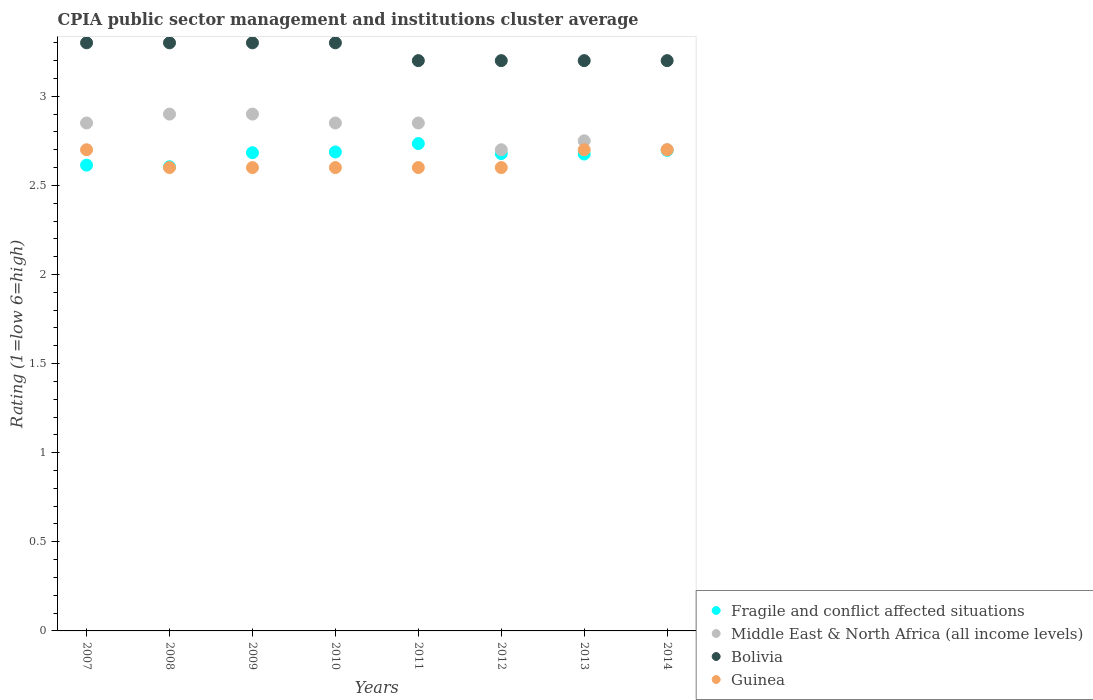Is the number of dotlines equal to the number of legend labels?
Make the answer very short. Yes. What is the CPIA rating in Fragile and conflict affected situations in 2008?
Ensure brevity in your answer.  2.6. Across all years, what is the maximum CPIA rating in Guinea?
Offer a terse response. 2.7. Across all years, what is the minimum CPIA rating in Fragile and conflict affected situations?
Offer a very short reply. 2.6. In which year was the CPIA rating in Middle East & North Africa (all income levels) maximum?
Make the answer very short. 2008. What is the total CPIA rating in Bolivia in the graph?
Make the answer very short. 26. What is the difference between the CPIA rating in Fragile and conflict affected situations in 2008 and that in 2013?
Keep it short and to the point. -0.07. What is the difference between the CPIA rating in Fragile and conflict affected situations in 2013 and the CPIA rating in Guinea in 2007?
Provide a short and direct response. -0.02. What is the average CPIA rating in Fragile and conflict affected situations per year?
Keep it short and to the point. 2.67. In the year 2007, what is the difference between the CPIA rating in Fragile and conflict affected situations and CPIA rating in Guinea?
Keep it short and to the point. -0.09. In how many years, is the CPIA rating in Middle East & North Africa (all income levels) greater than 0.8?
Your answer should be very brief. 8. Is the CPIA rating in Fragile and conflict affected situations in 2007 less than that in 2008?
Make the answer very short. No. Is the difference between the CPIA rating in Fragile and conflict affected situations in 2010 and 2013 greater than the difference between the CPIA rating in Guinea in 2010 and 2013?
Offer a terse response. Yes. What is the difference between the highest and the lowest CPIA rating in Bolivia?
Ensure brevity in your answer.  0.1. In how many years, is the CPIA rating in Middle East & North Africa (all income levels) greater than the average CPIA rating in Middle East & North Africa (all income levels) taken over all years?
Keep it short and to the point. 5. Is it the case that in every year, the sum of the CPIA rating in Bolivia and CPIA rating in Fragile and conflict affected situations  is greater than the sum of CPIA rating in Guinea and CPIA rating in Middle East & North Africa (all income levels)?
Provide a short and direct response. Yes. Does the CPIA rating in Middle East & North Africa (all income levels) monotonically increase over the years?
Your answer should be compact. No. Is the CPIA rating in Middle East & North Africa (all income levels) strictly less than the CPIA rating in Bolivia over the years?
Your answer should be very brief. Yes. How many dotlines are there?
Your answer should be very brief. 4. What is the difference between two consecutive major ticks on the Y-axis?
Keep it short and to the point. 0.5. Does the graph contain any zero values?
Provide a short and direct response. No. Does the graph contain grids?
Offer a very short reply. No. Where does the legend appear in the graph?
Provide a succinct answer. Bottom right. What is the title of the graph?
Keep it short and to the point. CPIA public sector management and institutions cluster average. What is the label or title of the Y-axis?
Give a very brief answer. Rating (1=low 6=high). What is the Rating (1=low 6=high) in Fragile and conflict affected situations in 2007?
Your answer should be compact. 2.61. What is the Rating (1=low 6=high) of Middle East & North Africa (all income levels) in 2007?
Your response must be concise. 2.85. What is the Rating (1=low 6=high) in Bolivia in 2007?
Provide a succinct answer. 3.3. What is the Rating (1=low 6=high) in Guinea in 2007?
Provide a succinct answer. 2.7. What is the Rating (1=low 6=high) in Fragile and conflict affected situations in 2008?
Keep it short and to the point. 2.6. What is the Rating (1=low 6=high) in Bolivia in 2008?
Provide a short and direct response. 3.3. What is the Rating (1=low 6=high) in Guinea in 2008?
Provide a succinct answer. 2.6. What is the Rating (1=low 6=high) of Fragile and conflict affected situations in 2009?
Offer a terse response. 2.68. What is the Rating (1=low 6=high) in Bolivia in 2009?
Give a very brief answer. 3.3. What is the Rating (1=low 6=high) of Fragile and conflict affected situations in 2010?
Keep it short and to the point. 2.69. What is the Rating (1=low 6=high) of Middle East & North Africa (all income levels) in 2010?
Ensure brevity in your answer.  2.85. What is the Rating (1=low 6=high) in Bolivia in 2010?
Ensure brevity in your answer.  3.3. What is the Rating (1=low 6=high) in Guinea in 2010?
Provide a succinct answer. 2.6. What is the Rating (1=low 6=high) of Fragile and conflict affected situations in 2011?
Ensure brevity in your answer.  2.73. What is the Rating (1=low 6=high) of Middle East & North Africa (all income levels) in 2011?
Offer a very short reply. 2.85. What is the Rating (1=low 6=high) of Bolivia in 2011?
Make the answer very short. 3.2. What is the Rating (1=low 6=high) in Fragile and conflict affected situations in 2012?
Provide a short and direct response. 2.68. What is the Rating (1=low 6=high) in Guinea in 2012?
Your answer should be very brief. 2.6. What is the Rating (1=low 6=high) of Fragile and conflict affected situations in 2013?
Provide a succinct answer. 2.68. What is the Rating (1=low 6=high) in Middle East & North Africa (all income levels) in 2013?
Your answer should be very brief. 2.75. What is the Rating (1=low 6=high) in Bolivia in 2013?
Your answer should be compact. 3.2. What is the Rating (1=low 6=high) of Guinea in 2013?
Give a very brief answer. 2.7. What is the Rating (1=low 6=high) of Fragile and conflict affected situations in 2014?
Your answer should be very brief. 2.7. What is the Rating (1=low 6=high) of Bolivia in 2014?
Give a very brief answer. 3.2. Across all years, what is the maximum Rating (1=low 6=high) of Fragile and conflict affected situations?
Your answer should be very brief. 2.73. Across all years, what is the maximum Rating (1=low 6=high) in Middle East & North Africa (all income levels)?
Give a very brief answer. 2.9. Across all years, what is the minimum Rating (1=low 6=high) in Fragile and conflict affected situations?
Ensure brevity in your answer.  2.6. Across all years, what is the minimum Rating (1=low 6=high) in Middle East & North Africa (all income levels)?
Your response must be concise. 2.7. Across all years, what is the minimum Rating (1=low 6=high) in Bolivia?
Ensure brevity in your answer.  3.2. What is the total Rating (1=low 6=high) of Fragile and conflict affected situations in the graph?
Provide a short and direct response. 21.37. What is the total Rating (1=low 6=high) of Middle East & North Africa (all income levels) in the graph?
Your answer should be very brief. 22.5. What is the total Rating (1=low 6=high) in Bolivia in the graph?
Provide a short and direct response. 26. What is the total Rating (1=low 6=high) of Guinea in the graph?
Provide a succinct answer. 21.1. What is the difference between the Rating (1=low 6=high) of Fragile and conflict affected situations in 2007 and that in 2008?
Provide a succinct answer. 0.01. What is the difference between the Rating (1=low 6=high) of Middle East & North Africa (all income levels) in 2007 and that in 2008?
Provide a succinct answer. -0.05. What is the difference between the Rating (1=low 6=high) of Bolivia in 2007 and that in 2008?
Your response must be concise. 0. What is the difference between the Rating (1=low 6=high) in Fragile and conflict affected situations in 2007 and that in 2009?
Offer a very short reply. -0.07. What is the difference between the Rating (1=low 6=high) in Fragile and conflict affected situations in 2007 and that in 2010?
Your answer should be compact. -0.07. What is the difference between the Rating (1=low 6=high) in Middle East & North Africa (all income levels) in 2007 and that in 2010?
Your answer should be compact. 0. What is the difference between the Rating (1=low 6=high) of Fragile and conflict affected situations in 2007 and that in 2011?
Ensure brevity in your answer.  -0.12. What is the difference between the Rating (1=low 6=high) of Middle East & North Africa (all income levels) in 2007 and that in 2011?
Keep it short and to the point. 0. What is the difference between the Rating (1=low 6=high) of Bolivia in 2007 and that in 2011?
Your answer should be compact. 0.1. What is the difference between the Rating (1=low 6=high) of Guinea in 2007 and that in 2011?
Ensure brevity in your answer.  0.1. What is the difference between the Rating (1=low 6=high) in Fragile and conflict affected situations in 2007 and that in 2012?
Ensure brevity in your answer.  -0.06. What is the difference between the Rating (1=low 6=high) in Middle East & North Africa (all income levels) in 2007 and that in 2012?
Provide a short and direct response. 0.15. What is the difference between the Rating (1=low 6=high) of Bolivia in 2007 and that in 2012?
Offer a terse response. 0.1. What is the difference between the Rating (1=low 6=high) in Guinea in 2007 and that in 2012?
Give a very brief answer. 0.1. What is the difference between the Rating (1=low 6=high) in Fragile and conflict affected situations in 2007 and that in 2013?
Ensure brevity in your answer.  -0.06. What is the difference between the Rating (1=low 6=high) in Bolivia in 2007 and that in 2013?
Keep it short and to the point. 0.1. What is the difference between the Rating (1=low 6=high) in Fragile and conflict affected situations in 2007 and that in 2014?
Give a very brief answer. -0.08. What is the difference between the Rating (1=low 6=high) in Guinea in 2007 and that in 2014?
Keep it short and to the point. 0. What is the difference between the Rating (1=low 6=high) in Fragile and conflict affected situations in 2008 and that in 2009?
Make the answer very short. -0.08. What is the difference between the Rating (1=low 6=high) of Bolivia in 2008 and that in 2009?
Make the answer very short. 0. What is the difference between the Rating (1=low 6=high) in Guinea in 2008 and that in 2009?
Provide a succinct answer. 0. What is the difference between the Rating (1=low 6=high) in Fragile and conflict affected situations in 2008 and that in 2010?
Ensure brevity in your answer.  -0.08. What is the difference between the Rating (1=low 6=high) of Fragile and conflict affected situations in 2008 and that in 2011?
Make the answer very short. -0.13. What is the difference between the Rating (1=low 6=high) of Fragile and conflict affected situations in 2008 and that in 2012?
Your response must be concise. -0.07. What is the difference between the Rating (1=low 6=high) of Guinea in 2008 and that in 2012?
Ensure brevity in your answer.  0. What is the difference between the Rating (1=low 6=high) of Fragile and conflict affected situations in 2008 and that in 2013?
Keep it short and to the point. -0.07. What is the difference between the Rating (1=low 6=high) of Guinea in 2008 and that in 2013?
Offer a very short reply. -0.1. What is the difference between the Rating (1=low 6=high) of Fragile and conflict affected situations in 2008 and that in 2014?
Provide a short and direct response. -0.09. What is the difference between the Rating (1=low 6=high) in Bolivia in 2008 and that in 2014?
Provide a succinct answer. 0.1. What is the difference between the Rating (1=low 6=high) in Guinea in 2008 and that in 2014?
Offer a terse response. -0.1. What is the difference between the Rating (1=low 6=high) of Fragile and conflict affected situations in 2009 and that in 2010?
Your answer should be compact. -0. What is the difference between the Rating (1=low 6=high) of Middle East & North Africa (all income levels) in 2009 and that in 2010?
Ensure brevity in your answer.  0.05. What is the difference between the Rating (1=low 6=high) in Bolivia in 2009 and that in 2010?
Your response must be concise. 0. What is the difference between the Rating (1=low 6=high) of Fragile and conflict affected situations in 2009 and that in 2011?
Your response must be concise. -0.05. What is the difference between the Rating (1=low 6=high) of Middle East & North Africa (all income levels) in 2009 and that in 2011?
Your response must be concise. 0.05. What is the difference between the Rating (1=low 6=high) in Bolivia in 2009 and that in 2011?
Your answer should be compact. 0.1. What is the difference between the Rating (1=low 6=high) in Fragile and conflict affected situations in 2009 and that in 2012?
Give a very brief answer. 0. What is the difference between the Rating (1=low 6=high) of Middle East & North Africa (all income levels) in 2009 and that in 2012?
Provide a succinct answer. 0.2. What is the difference between the Rating (1=low 6=high) of Fragile and conflict affected situations in 2009 and that in 2013?
Your answer should be very brief. 0.01. What is the difference between the Rating (1=low 6=high) in Middle East & North Africa (all income levels) in 2009 and that in 2013?
Keep it short and to the point. 0.15. What is the difference between the Rating (1=low 6=high) in Bolivia in 2009 and that in 2013?
Provide a succinct answer. 0.1. What is the difference between the Rating (1=low 6=high) in Fragile and conflict affected situations in 2009 and that in 2014?
Ensure brevity in your answer.  -0.01. What is the difference between the Rating (1=low 6=high) of Middle East & North Africa (all income levels) in 2009 and that in 2014?
Make the answer very short. 0.2. What is the difference between the Rating (1=low 6=high) of Bolivia in 2009 and that in 2014?
Keep it short and to the point. 0.1. What is the difference between the Rating (1=low 6=high) in Fragile and conflict affected situations in 2010 and that in 2011?
Provide a short and direct response. -0.05. What is the difference between the Rating (1=low 6=high) of Guinea in 2010 and that in 2011?
Ensure brevity in your answer.  0. What is the difference between the Rating (1=low 6=high) in Fragile and conflict affected situations in 2010 and that in 2012?
Your answer should be very brief. 0.01. What is the difference between the Rating (1=low 6=high) in Bolivia in 2010 and that in 2012?
Give a very brief answer. 0.1. What is the difference between the Rating (1=low 6=high) in Guinea in 2010 and that in 2012?
Keep it short and to the point. 0. What is the difference between the Rating (1=low 6=high) in Fragile and conflict affected situations in 2010 and that in 2013?
Give a very brief answer. 0.01. What is the difference between the Rating (1=low 6=high) in Guinea in 2010 and that in 2013?
Your answer should be very brief. -0.1. What is the difference between the Rating (1=low 6=high) in Fragile and conflict affected situations in 2010 and that in 2014?
Your answer should be very brief. -0.01. What is the difference between the Rating (1=low 6=high) of Bolivia in 2010 and that in 2014?
Give a very brief answer. 0.1. What is the difference between the Rating (1=low 6=high) in Fragile and conflict affected situations in 2011 and that in 2012?
Keep it short and to the point. 0.06. What is the difference between the Rating (1=low 6=high) of Middle East & North Africa (all income levels) in 2011 and that in 2012?
Keep it short and to the point. 0.15. What is the difference between the Rating (1=low 6=high) of Bolivia in 2011 and that in 2012?
Provide a succinct answer. 0. What is the difference between the Rating (1=low 6=high) of Fragile and conflict affected situations in 2011 and that in 2013?
Your answer should be very brief. 0.06. What is the difference between the Rating (1=low 6=high) in Bolivia in 2011 and that in 2013?
Provide a short and direct response. 0. What is the difference between the Rating (1=low 6=high) in Guinea in 2011 and that in 2013?
Give a very brief answer. -0.1. What is the difference between the Rating (1=low 6=high) in Fragile and conflict affected situations in 2011 and that in 2014?
Give a very brief answer. 0.04. What is the difference between the Rating (1=low 6=high) of Middle East & North Africa (all income levels) in 2011 and that in 2014?
Your response must be concise. 0.15. What is the difference between the Rating (1=low 6=high) of Fragile and conflict affected situations in 2012 and that in 2013?
Ensure brevity in your answer.  0. What is the difference between the Rating (1=low 6=high) of Bolivia in 2012 and that in 2013?
Ensure brevity in your answer.  0. What is the difference between the Rating (1=low 6=high) in Fragile and conflict affected situations in 2012 and that in 2014?
Offer a very short reply. -0.02. What is the difference between the Rating (1=low 6=high) in Middle East & North Africa (all income levels) in 2012 and that in 2014?
Offer a terse response. 0. What is the difference between the Rating (1=low 6=high) in Fragile and conflict affected situations in 2013 and that in 2014?
Ensure brevity in your answer.  -0.02. What is the difference between the Rating (1=low 6=high) of Middle East & North Africa (all income levels) in 2013 and that in 2014?
Keep it short and to the point. 0.05. What is the difference between the Rating (1=low 6=high) in Fragile and conflict affected situations in 2007 and the Rating (1=low 6=high) in Middle East & North Africa (all income levels) in 2008?
Offer a terse response. -0.29. What is the difference between the Rating (1=low 6=high) in Fragile and conflict affected situations in 2007 and the Rating (1=low 6=high) in Bolivia in 2008?
Make the answer very short. -0.69. What is the difference between the Rating (1=low 6=high) of Fragile and conflict affected situations in 2007 and the Rating (1=low 6=high) of Guinea in 2008?
Provide a succinct answer. 0.01. What is the difference between the Rating (1=low 6=high) in Middle East & North Africa (all income levels) in 2007 and the Rating (1=low 6=high) in Bolivia in 2008?
Your response must be concise. -0.45. What is the difference between the Rating (1=low 6=high) of Bolivia in 2007 and the Rating (1=low 6=high) of Guinea in 2008?
Offer a very short reply. 0.7. What is the difference between the Rating (1=low 6=high) in Fragile and conflict affected situations in 2007 and the Rating (1=low 6=high) in Middle East & North Africa (all income levels) in 2009?
Your answer should be compact. -0.29. What is the difference between the Rating (1=low 6=high) of Fragile and conflict affected situations in 2007 and the Rating (1=low 6=high) of Bolivia in 2009?
Make the answer very short. -0.69. What is the difference between the Rating (1=low 6=high) of Fragile and conflict affected situations in 2007 and the Rating (1=low 6=high) of Guinea in 2009?
Keep it short and to the point. 0.01. What is the difference between the Rating (1=low 6=high) of Middle East & North Africa (all income levels) in 2007 and the Rating (1=low 6=high) of Bolivia in 2009?
Your answer should be very brief. -0.45. What is the difference between the Rating (1=low 6=high) of Fragile and conflict affected situations in 2007 and the Rating (1=low 6=high) of Middle East & North Africa (all income levels) in 2010?
Offer a terse response. -0.24. What is the difference between the Rating (1=low 6=high) of Fragile and conflict affected situations in 2007 and the Rating (1=low 6=high) of Bolivia in 2010?
Make the answer very short. -0.69. What is the difference between the Rating (1=low 6=high) of Fragile and conflict affected situations in 2007 and the Rating (1=low 6=high) of Guinea in 2010?
Ensure brevity in your answer.  0.01. What is the difference between the Rating (1=low 6=high) of Middle East & North Africa (all income levels) in 2007 and the Rating (1=low 6=high) of Bolivia in 2010?
Your answer should be compact. -0.45. What is the difference between the Rating (1=low 6=high) of Middle East & North Africa (all income levels) in 2007 and the Rating (1=low 6=high) of Guinea in 2010?
Your answer should be compact. 0.25. What is the difference between the Rating (1=low 6=high) of Fragile and conflict affected situations in 2007 and the Rating (1=low 6=high) of Middle East & North Africa (all income levels) in 2011?
Ensure brevity in your answer.  -0.24. What is the difference between the Rating (1=low 6=high) of Fragile and conflict affected situations in 2007 and the Rating (1=low 6=high) of Bolivia in 2011?
Offer a terse response. -0.59. What is the difference between the Rating (1=low 6=high) in Fragile and conflict affected situations in 2007 and the Rating (1=low 6=high) in Guinea in 2011?
Offer a very short reply. 0.01. What is the difference between the Rating (1=low 6=high) in Middle East & North Africa (all income levels) in 2007 and the Rating (1=low 6=high) in Bolivia in 2011?
Give a very brief answer. -0.35. What is the difference between the Rating (1=low 6=high) in Middle East & North Africa (all income levels) in 2007 and the Rating (1=low 6=high) in Guinea in 2011?
Provide a succinct answer. 0.25. What is the difference between the Rating (1=low 6=high) in Fragile and conflict affected situations in 2007 and the Rating (1=low 6=high) in Middle East & North Africa (all income levels) in 2012?
Provide a short and direct response. -0.09. What is the difference between the Rating (1=low 6=high) of Fragile and conflict affected situations in 2007 and the Rating (1=low 6=high) of Bolivia in 2012?
Provide a succinct answer. -0.59. What is the difference between the Rating (1=low 6=high) of Fragile and conflict affected situations in 2007 and the Rating (1=low 6=high) of Guinea in 2012?
Your answer should be very brief. 0.01. What is the difference between the Rating (1=low 6=high) of Middle East & North Africa (all income levels) in 2007 and the Rating (1=low 6=high) of Bolivia in 2012?
Provide a short and direct response. -0.35. What is the difference between the Rating (1=low 6=high) in Middle East & North Africa (all income levels) in 2007 and the Rating (1=low 6=high) in Guinea in 2012?
Provide a succinct answer. 0.25. What is the difference between the Rating (1=low 6=high) in Fragile and conflict affected situations in 2007 and the Rating (1=low 6=high) in Middle East & North Africa (all income levels) in 2013?
Provide a short and direct response. -0.14. What is the difference between the Rating (1=low 6=high) in Fragile and conflict affected situations in 2007 and the Rating (1=low 6=high) in Bolivia in 2013?
Offer a terse response. -0.59. What is the difference between the Rating (1=low 6=high) in Fragile and conflict affected situations in 2007 and the Rating (1=low 6=high) in Guinea in 2013?
Your answer should be very brief. -0.09. What is the difference between the Rating (1=low 6=high) of Middle East & North Africa (all income levels) in 2007 and the Rating (1=low 6=high) of Bolivia in 2013?
Your answer should be very brief. -0.35. What is the difference between the Rating (1=low 6=high) of Fragile and conflict affected situations in 2007 and the Rating (1=low 6=high) of Middle East & North Africa (all income levels) in 2014?
Provide a succinct answer. -0.09. What is the difference between the Rating (1=low 6=high) in Fragile and conflict affected situations in 2007 and the Rating (1=low 6=high) in Bolivia in 2014?
Offer a terse response. -0.59. What is the difference between the Rating (1=low 6=high) of Fragile and conflict affected situations in 2007 and the Rating (1=low 6=high) of Guinea in 2014?
Offer a terse response. -0.09. What is the difference between the Rating (1=low 6=high) in Middle East & North Africa (all income levels) in 2007 and the Rating (1=low 6=high) in Bolivia in 2014?
Keep it short and to the point. -0.35. What is the difference between the Rating (1=low 6=high) of Middle East & North Africa (all income levels) in 2007 and the Rating (1=low 6=high) of Guinea in 2014?
Provide a succinct answer. 0.15. What is the difference between the Rating (1=low 6=high) in Fragile and conflict affected situations in 2008 and the Rating (1=low 6=high) in Middle East & North Africa (all income levels) in 2009?
Make the answer very short. -0.3. What is the difference between the Rating (1=low 6=high) in Fragile and conflict affected situations in 2008 and the Rating (1=low 6=high) in Bolivia in 2009?
Your answer should be very brief. -0.7. What is the difference between the Rating (1=low 6=high) in Fragile and conflict affected situations in 2008 and the Rating (1=low 6=high) in Guinea in 2009?
Keep it short and to the point. 0. What is the difference between the Rating (1=low 6=high) of Middle East & North Africa (all income levels) in 2008 and the Rating (1=low 6=high) of Bolivia in 2009?
Make the answer very short. -0.4. What is the difference between the Rating (1=low 6=high) in Middle East & North Africa (all income levels) in 2008 and the Rating (1=low 6=high) in Guinea in 2009?
Your response must be concise. 0.3. What is the difference between the Rating (1=low 6=high) in Fragile and conflict affected situations in 2008 and the Rating (1=low 6=high) in Middle East & North Africa (all income levels) in 2010?
Your response must be concise. -0.25. What is the difference between the Rating (1=low 6=high) of Fragile and conflict affected situations in 2008 and the Rating (1=low 6=high) of Bolivia in 2010?
Offer a terse response. -0.7. What is the difference between the Rating (1=low 6=high) in Fragile and conflict affected situations in 2008 and the Rating (1=low 6=high) in Guinea in 2010?
Your response must be concise. 0. What is the difference between the Rating (1=low 6=high) in Middle East & North Africa (all income levels) in 2008 and the Rating (1=low 6=high) in Bolivia in 2010?
Ensure brevity in your answer.  -0.4. What is the difference between the Rating (1=low 6=high) of Middle East & North Africa (all income levels) in 2008 and the Rating (1=low 6=high) of Guinea in 2010?
Your response must be concise. 0.3. What is the difference between the Rating (1=low 6=high) of Fragile and conflict affected situations in 2008 and the Rating (1=low 6=high) of Middle East & North Africa (all income levels) in 2011?
Provide a short and direct response. -0.25. What is the difference between the Rating (1=low 6=high) of Fragile and conflict affected situations in 2008 and the Rating (1=low 6=high) of Bolivia in 2011?
Your answer should be compact. -0.6. What is the difference between the Rating (1=low 6=high) of Fragile and conflict affected situations in 2008 and the Rating (1=low 6=high) of Guinea in 2011?
Give a very brief answer. 0. What is the difference between the Rating (1=low 6=high) of Middle East & North Africa (all income levels) in 2008 and the Rating (1=low 6=high) of Bolivia in 2011?
Provide a succinct answer. -0.3. What is the difference between the Rating (1=low 6=high) of Middle East & North Africa (all income levels) in 2008 and the Rating (1=low 6=high) of Guinea in 2011?
Offer a terse response. 0.3. What is the difference between the Rating (1=low 6=high) of Fragile and conflict affected situations in 2008 and the Rating (1=low 6=high) of Middle East & North Africa (all income levels) in 2012?
Your response must be concise. -0.1. What is the difference between the Rating (1=low 6=high) of Fragile and conflict affected situations in 2008 and the Rating (1=low 6=high) of Bolivia in 2012?
Give a very brief answer. -0.6. What is the difference between the Rating (1=low 6=high) in Fragile and conflict affected situations in 2008 and the Rating (1=low 6=high) in Guinea in 2012?
Make the answer very short. 0. What is the difference between the Rating (1=low 6=high) of Bolivia in 2008 and the Rating (1=low 6=high) of Guinea in 2012?
Make the answer very short. 0.7. What is the difference between the Rating (1=low 6=high) of Fragile and conflict affected situations in 2008 and the Rating (1=low 6=high) of Middle East & North Africa (all income levels) in 2013?
Ensure brevity in your answer.  -0.15. What is the difference between the Rating (1=low 6=high) of Fragile and conflict affected situations in 2008 and the Rating (1=low 6=high) of Bolivia in 2013?
Your answer should be compact. -0.6. What is the difference between the Rating (1=low 6=high) in Fragile and conflict affected situations in 2008 and the Rating (1=low 6=high) in Guinea in 2013?
Offer a terse response. -0.1. What is the difference between the Rating (1=low 6=high) of Bolivia in 2008 and the Rating (1=low 6=high) of Guinea in 2013?
Provide a short and direct response. 0.6. What is the difference between the Rating (1=low 6=high) of Fragile and conflict affected situations in 2008 and the Rating (1=low 6=high) of Middle East & North Africa (all income levels) in 2014?
Give a very brief answer. -0.1. What is the difference between the Rating (1=low 6=high) of Fragile and conflict affected situations in 2008 and the Rating (1=low 6=high) of Bolivia in 2014?
Your response must be concise. -0.6. What is the difference between the Rating (1=low 6=high) of Fragile and conflict affected situations in 2008 and the Rating (1=low 6=high) of Guinea in 2014?
Give a very brief answer. -0.1. What is the difference between the Rating (1=low 6=high) in Middle East & North Africa (all income levels) in 2008 and the Rating (1=low 6=high) in Guinea in 2014?
Make the answer very short. 0.2. What is the difference between the Rating (1=low 6=high) in Fragile and conflict affected situations in 2009 and the Rating (1=low 6=high) in Middle East & North Africa (all income levels) in 2010?
Offer a terse response. -0.17. What is the difference between the Rating (1=low 6=high) of Fragile and conflict affected situations in 2009 and the Rating (1=low 6=high) of Bolivia in 2010?
Ensure brevity in your answer.  -0.62. What is the difference between the Rating (1=low 6=high) of Fragile and conflict affected situations in 2009 and the Rating (1=low 6=high) of Guinea in 2010?
Your response must be concise. 0.08. What is the difference between the Rating (1=low 6=high) in Middle East & North Africa (all income levels) in 2009 and the Rating (1=low 6=high) in Bolivia in 2010?
Your answer should be compact. -0.4. What is the difference between the Rating (1=low 6=high) of Fragile and conflict affected situations in 2009 and the Rating (1=low 6=high) of Bolivia in 2011?
Provide a short and direct response. -0.52. What is the difference between the Rating (1=low 6=high) of Fragile and conflict affected situations in 2009 and the Rating (1=low 6=high) of Guinea in 2011?
Ensure brevity in your answer.  0.08. What is the difference between the Rating (1=low 6=high) in Middle East & North Africa (all income levels) in 2009 and the Rating (1=low 6=high) in Bolivia in 2011?
Give a very brief answer. -0.3. What is the difference between the Rating (1=low 6=high) in Bolivia in 2009 and the Rating (1=low 6=high) in Guinea in 2011?
Your answer should be very brief. 0.7. What is the difference between the Rating (1=low 6=high) of Fragile and conflict affected situations in 2009 and the Rating (1=low 6=high) of Middle East & North Africa (all income levels) in 2012?
Your response must be concise. -0.02. What is the difference between the Rating (1=low 6=high) of Fragile and conflict affected situations in 2009 and the Rating (1=low 6=high) of Bolivia in 2012?
Provide a short and direct response. -0.52. What is the difference between the Rating (1=low 6=high) of Fragile and conflict affected situations in 2009 and the Rating (1=low 6=high) of Guinea in 2012?
Keep it short and to the point. 0.08. What is the difference between the Rating (1=low 6=high) of Fragile and conflict affected situations in 2009 and the Rating (1=low 6=high) of Middle East & North Africa (all income levels) in 2013?
Offer a terse response. -0.07. What is the difference between the Rating (1=low 6=high) in Fragile and conflict affected situations in 2009 and the Rating (1=low 6=high) in Bolivia in 2013?
Your answer should be very brief. -0.52. What is the difference between the Rating (1=low 6=high) in Fragile and conflict affected situations in 2009 and the Rating (1=low 6=high) in Guinea in 2013?
Your answer should be compact. -0.02. What is the difference between the Rating (1=low 6=high) of Middle East & North Africa (all income levels) in 2009 and the Rating (1=low 6=high) of Bolivia in 2013?
Offer a very short reply. -0.3. What is the difference between the Rating (1=low 6=high) in Middle East & North Africa (all income levels) in 2009 and the Rating (1=low 6=high) in Guinea in 2013?
Provide a succinct answer. 0.2. What is the difference between the Rating (1=low 6=high) in Bolivia in 2009 and the Rating (1=low 6=high) in Guinea in 2013?
Your response must be concise. 0.6. What is the difference between the Rating (1=low 6=high) in Fragile and conflict affected situations in 2009 and the Rating (1=low 6=high) in Middle East & North Africa (all income levels) in 2014?
Provide a succinct answer. -0.02. What is the difference between the Rating (1=low 6=high) in Fragile and conflict affected situations in 2009 and the Rating (1=low 6=high) in Bolivia in 2014?
Make the answer very short. -0.52. What is the difference between the Rating (1=low 6=high) of Fragile and conflict affected situations in 2009 and the Rating (1=low 6=high) of Guinea in 2014?
Your answer should be very brief. -0.02. What is the difference between the Rating (1=low 6=high) in Middle East & North Africa (all income levels) in 2009 and the Rating (1=low 6=high) in Bolivia in 2014?
Offer a terse response. -0.3. What is the difference between the Rating (1=low 6=high) in Middle East & North Africa (all income levels) in 2009 and the Rating (1=low 6=high) in Guinea in 2014?
Make the answer very short. 0.2. What is the difference between the Rating (1=low 6=high) of Fragile and conflict affected situations in 2010 and the Rating (1=low 6=high) of Middle East & North Africa (all income levels) in 2011?
Your response must be concise. -0.16. What is the difference between the Rating (1=low 6=high) in Fragile and conflict affected situations in 2010 and the Rating (1=low 6=high) in Bolivia in 2011?
Your response must be concise. -0.51. What is the difference between the Rating (1=low 6=high) of Fragile and conflict affected situations in 2010 and the Rating (1=low 6=high) of Guinea in 2011?
Keep it short and to the point. 0.09. What is the difference between the Rating (1=low 6=high) in Middle East & North Africa (all income levels) in 2010 and the Rating (1=low 6=high) in Bolivia in 2011?
Your answer should be very brief. -0.35. What is the difference between the Rating (1=low 6=high) of Fragile and conflict affected situations in 2010 and the Rating (1=low 6=high) of Middle East & North Africa (all income levels) in 2012?
Your answer should be compact. -0.01. What is the difference between the Rating (1=low 6=high) in Fragile and conflict affected situations in 2010 and the Rating (1=low 6=high) in Bolivia in 2012?
Offer a very short reply. -0.51. What is the difference between the Rating (1=low 6=high) of Fragile and conflict affected situations in 2010 and the Rating (1=low 6=high) of Guinea in 2012?
Give a very brief answer. 0.09. What is the difference between the Rating (1=low 6=high) in Middle East & North Africa (all income levels) in 2010 and the Rating (1=low 6=high) in Bolivia in 2012?
Provide a succinct answer. -0.35. What is the difference between the Rating (1=low 6=high) in Middle East & North Africa (all income levels) in 2010 and the Rating (1=low 6=high) in Guinea in 2012?
Ensure brevity in your answer.  0.25. What is the difference between the Rating (1=low 6=high) in Bolivia in 2010 and the Rating (1=low 6=high) in Guinea in 2012?
Make the answer very short. 0.7. What is the difference between the Rating (1=low 6=high) in Fragile and conflict affected situations in 2010 and the Rating (1=low 6=high) in Middle East & North Africa (all income levels) in 2013?
Your answer should be very brief. -0.06. What is the difference between the Rating (1=low 6=high) in Fragile and conflict affected situations in 2010 and the Rating (1=low 6=high) in Bolivia in 2013?
Make the answer very short. -0.51. What is the difference between the Rating (1=low 6=high) of Fragile and conflict affected situations in 2010 and the Rating (1=low 6=high) of Guinea in 2013?
Keep it short and to the point. -0.01. What is the difference between the Rating (1=low 6=high) in Middle East & North Africa (all income levels) in 2010 and the Rating (1=low 6=high) in Bolivia in 2013?
Provide a short and direct response. -0.35. What is the difference between the Rating (1=low 6=high) of Middle East & North Africa (all income levels) in 2010 and the Rating (1=low 6=high) of Guinea in 2013?
Your response must be concise. 0.15. What is the difference between the Rating (1=low 6=high) in Bolivia in 2010 and the Rating (1=low 6=high) in Guinea in 2013?
Ensure brevity in your answer.  0.6. What is the difference between the Rating (1=low 6=high) in Fragile and conflict affected situations in 2010 and the Rating (1=low 6=high) in Middle East & North Africa (all income levels) in 2014?
Your answer should be compact. -0.01. What is the difference between the Rating (1=low 6=high) in Fragile and conflict affected situations in 2010 and the Rating (1=low 6=high) in Bolivia in 2014?
Provide a short and direct response. -0.51. What is the difference between the Rating (1=low 6=high) of Fragile and conflict affected situations in 2010 and the Rating (1=low 6=high) of Guinea in 2014?
Offer a very short reply. -0.01. What is the difference between the Rating (1=low 6=high) of Middle East & North Africa (all income levels) in 2010 and the Rating (1=low 6=high) of Bolivia in 2014?
Keep it short and to the point. -0.35. What is the difference between the Rating (1=low 6=high) of Middle East & North Africa (all income levels) in 2010 and the Rating (1=low 6=high) of Guinea in 2014?
Provide a short and direct response. 0.15. What is the difference between the Rating (1=low 6=high) of Fragile and conflict affected situations in 2011 and the Rating (1=low 6=high) of Middle East & North Africa (all income levels) in 2012?
Offer a very short reply. 0.03. What is the difference between the Rating (1=low 6=high) of Fragile and conflict affected situations in 2011 and the Rating (1=low 6=high) of Bolivia in 2012?
Your answer should be very brief. -0.47. What is the difference between the Rating (1=low 6=high) in Fragile and conflict affected situations in 2011 and the Rating (1=low 6=high) in Guinea in 2012?
Make the answer very short. 0.13. What is the difference between the Rating (1=low 6=high) in Middle East & North Africa (all income levels) in 2011 and the Rating (1=low 6=high) in Bolivia in 2012?
Your answer should be very brief. -0.35. What is the difference between the Rating (1=low 6=high) in Bolivia in 2011 and the Rating (1=low 6=high) in Guinea in 2012?
Your answer should be very brief. 0.6. What is the difference between the Rating (1=low 6=high) in Fragile and conflict affected situations in 2011 and the Rating (1=low 6=high) in Middle East & North Africa (all income levels) in 2013?
Offer a terse response. -0.02. What is the difference between the Rating (1=low 6=high) in Fragile and conflict affected situations in 2011 and the Rating (1=low 6=high) in Bolivia in 2013?
Offer a terse response. -0.47. What is the difference between the Rating (1=low 6=high) of Fragile and conflict affected situations in 2011 and the Rating (1=low 6=high) of Guinea in 2013?
Your response must be concise. 0.03. What is the difference between the Rating (1=low 6=high) in Middle East & North Africa (all income levels) in 2011 and the Rating (1=low 6=high) in Bolivia in 2013?
Give a very brief answer. -0.35. What is the difference between the Rating (1=low 6=high) in Fragile and conflict affected situations in 2011 and the Rating (1=low 6=high) in Middle East & North Africa (all income levels) in 2014?
Your response must be concise. 0.03. What is the difference between the Rating (1=low 6=high) of Fragile and conflict affected situations in 2011 and the Rating (1=low 6=high) of Bolivia in 2014?
Ensure brevity in your answer.  -0.47. What is the difference between the Rating (1=low 6=high) of Fragile and conflict affected situations in 2011 and the Rating (1=low 6=high) of Guinea in 2014?
Your response must be concise. 0.03. What is the difference between the Rating (1=low 6=high) of Middle East & North Africa (all income levels) in 2011 and the Rating (1=low 6=high) of Bolivia in 2014?
Provide a succinct answer. -0.35. What is the difference between the Rating (1=low 6=high) of Bolivia in 2011 and the Rating (1=low 6=high) of Guinea in 2014?
Offer a terse response. 0.5. What is the difference between the Rating (1=low 6=high) in Fragile and conflict affected situations in 2012 and the Rating (1=low 6=high) in Middle East & North Africa (all income levels) in 2013?
Your response must be concise. -0.07. What is the difference between the Rating (1=low 6=high) in Fragile and conflict affected situations in 2012 and the Rating (1=low 6=high) in Bolivia in 2013?
Keep it short and to the point. -0.52. What is the difference between the Rating (1=low 6=high) in Fragile and conflict affected situations in 2012 and the Rating (1=low 6=high) in Guinea in 2013?
Ensure brevity in your answer.  -0.02. What is the difference between the Rating (1=low 6=high) of Middle East & North Africa (all income levels) in 2012 and the Rating (1=low 6=high) of Bolivia in 2013?
Keep it short and to the point. -0.5. What is the difference between the Rating (1=low 6=high) of Middle East & North Africa (all income levels) in 2012 and the Rating (1=low 6=high) of Guinea in 2013?
Provide a short and direct response. 0. What is the difference between the Rating (1=low 6=high) of Bolivia in 2012 and the Rating (1=low 6=high) of Guinea in 2013?
Give a very brief answer. 0.5. What is the difference between the Rating (1=low 6=high) in Fragile and conflict affected situations in 2012 and the Rating (1=low 6=high) in Middle East & North Africa (all income levels) in 2014?
Provide a short and direct response. -0.02. What is the difference between the Rating (1=low 6=high) of Fragile and conflict affected situations in 2012 and the Rating (1=low 6=high) of Bolivia in 2014?
Keep it short and to the point. -0.52. What is the difference between the Rating (1=low 6=high) of Fragile and conflict affected situations in 2012 and the Rating (1=low 6=high) of Guinea in 2014?
Keep it short and to the point. -0.02. What is the difference between the Rating (1=low 6=high) in Middle East & North Africa (all income levels) in 2012 and the Rating (1=low 6=high) in Bolivia in 2014?
Your answer should be compact. -0.5. What is the difference between the Rating (1=low 6=high) in Middle East & North Africa (all income levels) in 2012 and the Rating (1=low 6=high) in Guinea in 2014?
Keep it short and to the point. 0. What is the difference between the Rating (1=low 6=high) in Bolivia in 2012 and the Rating (1=low 6=high) in Guinea in 2014?
Provide a succinct answer. 0.5. What is the difference between the Rating (1=low 6=high) in Fragile and conflict affected situations in 2013 and the Rating (1=low 6=high) in Middle East & North Africa (all income levels) in 2014?
Your answer should be very brief. -0.02. What is the difference between the Rating (1=low 6=high) in Fragile and conflict affected situations in 2013 and the Rating (1=low 6=high) in Bolivia in 2014?
Your response must be concise. -0.52. What is the difference between the Rating (1=low 6=high) of Fragile and conflict affected situations in 2013 and the Rating (1=low 6=high) of Guinea in 2014?
Your answer should be very brief. -0.02. What is the difference between the Rating (1=low 6=high) in Middle East & North Africa (all income levels) in 2013 and the Rating (1=low 6=high) in Bolivia in 2014?
Make the answer very short. -0.45. What is the difference between the Rating (1=low 6=high) of Middle East & North Africa (all income levels) in 2013 and the Rating (1=low 6=high) of Guinea in 2014?
Keep it short and to the point. 0.05. What is the difference between the Rating (1=low 6=high) of Bolivia in 2013 and the Rating (1=low 6=high) of Guinea in 2014?
Your response must be concise. 0.5. What is the average Rating (1=low 6=high) in Fragile and conflict affected situations per year?
Ensure brevity in your answer.  2.67. What is the average Rating (1=low 6=high) in Middle East & North Africa (all income levels) per year?
Your response must be concise. 2.81. What is the average Rating (1=low 6=high) of Bolivia per year?
Provide a succinct answer. 3.25. What is the average Rating (1=low 6=high) in Guinea per year?
Your response must be concise. 2.64. In the year 2007, what is the difference between the Rating (1=low 6=high) of Fragile and conflict affected situations and Rating (1=low 6=high) of Middle East & North Africa (all income levels)?
Offer a terse response. -0.24. In the year 2007, what is the difference between the Rating (1=low 6=high) in Fragile and conflict affected situations and Rating (1=low 6=high) in Bolivia?
Offer a very short reply. -0.69. In the year 2007, what is the difference between the Rating (1=low 6=high) of Fragile and conflict affected situations and Rating (1=low 6=high) of Guinea?
Your response must be concise. -0.09. In the year 2007, what is the difference between the Rating (1=low 6=high) in Middle East & North Africa (all income levels) and Rating (1=low 6=high) in Bolivia?
Ensure brevity in your answer.  -0.45. In the year 2007, what is the difference between the Rating (1=low 6=high) in Middle East & North Africa (all income levels) and Rating (1=low 6=high) in Guinea?
Offer a very short reply. 0.15. In the year 2008, what is the difference between the Rating (1=low 6=high) of Fragile and conflict affected situations and Rating (1=low 6=high) of Middle East & North Africa (all income levels)?
Give a very brief answer. -0.3. In the year 2008, what is the difference between the Rating (1=low 6=high) in Fragile and conflict affected situations and Rating (1=low 6=high) in Bolivia?
Provide a short and direct response. -0.7. In the year 2008, what is the difference between the Rating (1=low 6=high) of Fragile and conflict affected situations and Rating (1=low 6=high) of Guinea?
Provide a succinct answer. 0. In the year 2008, what is the difference between the Rating (1=low 6=high) in Middle East & North Africa (all income levels) and Rating (1=low 6=high) in Guinea?
Offer a very short reply. 0.3. In the year 2009, what is the difference between the Rating (1=low 6=high) in Fragile and conflict affected situations and Rating (1=low 6=high) in Middle East & North Africa (all income levels)?
Make the answer very short. -0.22. In the year 2009, what is the difference between the Rating (1=low 6=high) of Fragile and conflict affected situations and Rating (1=low 6=high) of Bolivia?
Provide a succinct answer. -0.62. In the year 2009, what is the difference between the Rating (1=low 6=high) of Fragile and conflict affected situations and Rating (1=low 6=high) of Guinea?
Provide a succinct answer. 0.08. In the year 2009, what is the difference between the Rating (1=low 6=high) in Middle East & North Africa (all income levels) and Rating (1=low 6=high) in Guinea?
Offer a very short reply. 0.3. In the year 2010, what is the difference between the Rating (1=low 6=high) in Fragile and conflict affected situations and Rating (1=low 6=high) in Middle East & North Africa (all income levels)?
Your answer should be compact. -0.16. In the year 2010, what is the difference between the Rating (1=low 6=high) of Fragile and conflict affected situations and Rating (1=low 6=high) of Bolivia?
Offer a very short reply. -0.61. In the year 2010, what is the difference between the Rating (1=low 6=high) in Fragile and conflict affected situations and Rating (1=low 6=high) in Guinea?
Give a very brief answer. 0.09. In the year 2010, what is the difference between the Rating (1=low 6=high) of Middle East & North Africa (all income levels) and Rating (1=low 6=high) of Bolivia?
Offer a very short reply. -0.45. In the year 2010, what is the difference between the Rating (1=low 6=high) of Middle East & North Africa (all income levels) and Rating (1=low 6=high) of Guinea?
Offer a very short reply. 0.25. In the year 2010, what is the difference between the Rating (1=low 6=high) of Bolivia and Rating (1=low 6=high) of Guinea?
Give a very brief answer. 0.7. In the year 2011, what is the difference between the Rating (1=low 6=high) in Fragile and conflict affected situations and Rating (1=low 6=high) in Middle East & North Africa (all income levels)?
Provide a short and direct response. -0.12. In the year 2011, what is the difference between the Rating (1=low 6=high) in Fragile and conflict affected situations and Rating (1=low 6=high) in Bolivia?
Keep it short and to the point. -0.47. In the year 2011, what is the difference between the Rating (1=low 6=high) of Fragile and conflict affected situations and Rating (1=low 6=high) of Guinea?
Make the answer very short. 0.13. In the year 2011, what is the difference between the Rating (1=low 6=high) of Middle East & North Africa (all income levels) and Rating (1=low 6=high) of Bolivia?
Provide a succinct answer. -0.35. In the year 2012, what is the difference between the Rating (1=low 6=high) in Fragile and conflict affected situations and Rating (1=low 6=high) in Middle East & North Africa (all income levels)?
Keep it short and to the point. -0.02. In the year 2012, what is the difference between the Rating (1=low 6=high) in Fragile and conflict affected situations and Rating (1=low 6=high) in Bolivia?
Offer a very short reply. -0.52. In the year 2012, what is the difference between the Rating (1=low 6=high) in Fragile and conflict affected situations and Rating (1=low 6=high) in Guinea?
Provide a short and direct response. 0.08. In the year 2012, what is the difference between the Rating (1=low 6=high) of Middle East & North Africa (all income levels) and Rating (1=low 6=high) of Bolivia?
Ensure brevity in your answer.  -0.5. In the year 2012, what is the difference between the Rating (1=low 6=high) of Bolivia and Rating (1=low 6=high) of Guinea?
Provide a succinct answer. 0.6. In the year 2013, what is the difference between the Rating (1=low 6=high) of Fragile and conflict affected situations and Rating (1=low 6=high) of Middle East & North Africa (all income levels)?
Provide a short and direct response. -0.07. In the year 2013, what is the difference between the Rating (1=low 6=high) in Fragile and conflict affected situations and Rating (1=low 6=high) in Bolivia?
Offer a terse response. -0.52. In the year 2013, what is the difference between the Rating (1=low 6=high) of Fragile and conflict affected situations and Rating (1=low 6=high) of Guinea?
Offer a terse response. -0.02. In the year 2013, what is the difference between the Rating (1=low 6=high) in Middle East & North Africa (all income levels) and Rating (1=low 6=high) in Bolivia?
Keep it short and to the point. -0.45. In the year 2014, what is the difference between the Rating (1=low 6=high) of Fragile and conflict affected situations and Rating (1=low 6=high) of Middle East & North Africa (all income levels)?
Ensure brevity in your answer.  -0. In the year 2014, what is the difference between the Rating (1=low 6=high) in Fragile and conflict affected situations and Rating (1=low 6=high) in Bolivia?
Your answer should be compact. -0.5. In the year 2014, what is the difference between the Rating (1=low 6=high) of Fragile and conflict affected situations and Rating (1=low 6=high) of Guinea?
Ensure brevity in your answer.  -0. In the year 2014, what is the difference between the Rating (1=low 6=high) in Middle East & North Africa (all income levels) and Rating (1=low 6=high) in Bolivia?
Your response must be concise. -0.5. In the year 2014, what is the difference between the Rating (1=low 6=high) in Middle East & North Africa (all income levels) and Rating (1=low 6=high) in Guinea?
Your response must be concise. 0. What is the ratio of the Rating (1=low 6=high) in Middle East & North Africa (all income levels) in 2007 to that in 2008?
Your response must be concise. 0.98. What is the ratio of the Rating (1=low 6=high) of Fragile and conflict affected situations in 2007 to that in 2009?
Give a very brief answer. 0.97. What is the ratio of the Rating (1=low 6=high) in Middle East & North Africa (all income levels) in 2007 to that in 2009?
Offer a terse response. 0.98. What is the ratio of the Rating (1=low 6=high) of Bolivia in 2007 to that in 2009?
Provide a succinct answer. 1. What is the ratio of the Rating (1=low 6=high) of Fragile and conflict affected situations in 2007 to that in 2010?
Make the answer very short. 0.97. What is the ratio of the Rating (1=low 6=high) of Middle East & North Africa (all income levels) in 2007 to that in 2010?
Your answer should be compact. 1. What is the ratio of the Rating (1=low 6=high) in Bolivia in 2007 to that in 2010?
Your answer should be compact. 1. What is the ratio of the Rating (1=low 6=high) of Fragile and conflict affected situations in 2007 to that in 2011?
Your answer should be very brief. 0.96. What is the ratio of the Rating (1=low 6=high) in Middle East & North Africa (all income levels) in 2007 to that in 2011?
Offer a very short reply. 1. What is the ratio of the Rating (1=low 6=high) of Bolivia in 2007 to that in 2011?
Provide a succinct answer. 1.03. What is the ratio of the Rating (1=low 6=high) in Fragile and conflict affected situations in 2007 to that in 2012?
Your response must be concise. 0.98. What is the ratio of the Rating (1=low 6=high) in Middle East & North Africa (all income levels) in 2007 to that in 2012?
Your answer should be very brief. 1.06. What is the ratio of the Rating (1=low 6=high) in Bolivia in 2007 to that in 2012?
Ensure brevity in your answer.  1.03. What is the ratio of the Rating (1=low 6=high) of Guinea in 2007 to that in 2012?
Offer a terse response. 1.04. What is the ratio of the Rating (1=low 6=high) of Fragile and conflict affected situations in 2007 to that in 2013?
Your answer should be compact. 0.98. What is the ratio of the Rating (1=low 6=high) in Middle East & North Africa (all income levels) in 2007 to that in 2013?
Offer a very short reply. 1.04. What is the ratio of the Rating (1=low 6=high) in Bolivia in 2007 to that in 2013?
Your response must be concise. 1.03. What is the ratio of the Rating (1=low 6=high) of Fragile and conflict affected situations in 2007 to that in 2014?
Provide a succinct answer. 0.97. What is the ratio of the Rating (1=low 6=high) in Middle East & North Africa (all income levels) in 2007 to that in 2014?
Give a very brief answer. 1.06. What is the ratio of the Rating (1=low 6=high) in Bolivia in 2007 to that in 2014?
Make the answer very short. 1.03. What is the ratio of the Rating (1=low 6=high) in Guinea in 2007 to that in 2014?
Give a very brief answer. 1. What is the ratio of the Rating (1=low 6=high) in Fragile and conflict affected situations in 2008 to that in 2009?
Your response must be concise. 0.97. What is the ratio of the Rating (1=low 6=high) of Middle East & North Africa (all income levels) in 2008 to that in 2009?
Make the answer very short. 1. What is the ratio of the Rating (1=low 6=high) in Guinea in 2008 to that in 2009?
Offer a terse response. 1. What is the ratio of the Rating (1=low 6=high) in Fragile and conflict affected situations in 2008 to that in 2010?
Make the answer very short. 0.97. What is the ratio of the Rating (1=low 6=high) of Middle East & North Africa (all income levels) in 2008 to that in 2010?
Your answer should be very brief. 1.02. What is the ratio of the Rating (1=low 6=high) in Fragile and conflict affected situations in 2008 to that in 2011?
Provide a short and direct response. 0.95. What is the ratio of the Rating (1=low 6=high) of Middle East & North Africa (all income levels) in 2008 to that in 2011?
Provide a short and direct response. 1.02. What is the ratio of the Rating (1=low 6=high) of Bolivia in 2008 to that in 2011?
Offer a terse response. 1.03. What is the ratio of the Rating (1=low 6=high) of Fragile and conflict affected situations in 2008 to that in 2012?
Provide a succinct answer. 0.97. What is the ratio of the Rating (1=low 6=high) in Middle East & North Africa (all income levels) in 2008 to that in 2012?
Keep it short and to the point. 1.07. What is the ratio of the Rating (1=low 6=high) of Bolivia in 2008 to that in 2012?
Provide a short and direct response. 1.03. What is the ratio of the Rating (1=low 6=high) in Guinea in 2008 to that in 2012?
Provide a succinct answer. 1. What is the ratio of the Rating (1=low 6=high) in Fragile and conflict affected situations in 2008 to that in 2013?
Give a very brief answer. 0.97. What is the ratio of the Rating (1=low 6=high) in Middle East & North Africa (all income levels) in 2008 to that in 2013?
Offer a very short reply. 1.05. What is the ratio of the Rating (1=low 6=high) in Bolivia in 2008 to that in 2013?
Ensure brevity in your answer.  1.03. What is the ratio of the Rating (1=low 6=high) in Guinea in 2008 to that in 2013?
Your answer should be very brief. 0.96. What is the ratio of the Rating (1=low 6=high) in Fragile and conflict affected situations in 2008 to that in 2014?
Provide a succinct answer. 0.97. What is the ratio of the Rating (1=low 6=high) in Middle East & North Africa (all income levels) in 2008 to that in 2014?
Provide a short and direct response. 1.07. What is the ratio of the Rating (1=low 6=high) of Bolivia in 2008 to that in 2014?
Your response must be concise. 1.03. What is the ratio of the Rating (1=low 6=high) of Guinea in 2008 to that in 2014?
Your answer should be very brief. 0.96. What is the ratio of the Rating (1=low 6=high) in Middle East & North Africa (all income levels) in 2009 to that in 2010?
Your answer should be compact. 1.02. What is the ratio of the Rating (1=low 6=high) in Bolivia in 2009 to that in 2010?
Offer a terse response. 1. What is the ratio of the Rating (1=low 6=high) of Guinea in 2009 to that in 2010?
Ensure brevity in your answer.  1. What is the ratio of the Rating (1=low 6=high) of Fragile and conflict affected situations in 2009 to that in 2011?
Your answer should be compact. 0.98. What is the ratio of the Rating (1=low 6=high) in Middle East & North Africa (all income levels) in 2009 to that in 2011?
Provide a short and direct response. 1.02. What is the ratio of the Rating (1=low 6=high) of Bolivia in 2009 to that in 2011?
Provide a succinct answer. 1.03. What is the ratio of the Rating (1=low 6=high) in Fragile and conflict affected situations in 2009 to that in 2012?
Ensure brevity in your answer.  1. What is the ratio of the Rating (1=low 6=high) in Middle East & North Africa (all income levels) in 2009 to that in 2012?
Ensure brevity in your answer.  1.07. What is the ratio of the Rating (1=low 6=high) in Bolivia in 2009 to that in 2012?
Offer a terse response. 1.03. What is the ratio of the Rating (1=low 6=high) of Fragile and conflict affected situations in 2009 to that in 2013?
Keep it short and to the point. 1. What is the ratio of the Rating (1=low 6=high) in Middle East & North Africa (all income levels) in 2009 to that in 2013?
Provide a short and direct response. 1.05. What is the ratio of the Rating (1=low 6=high) in Bolivia in 2009 to that in 2013?
Provide a succinct answer. 1.03. What is the ratio of the Rating (1=low 6=high) in Fragile and conflict affected situations in 2009 to that in 2014?
Your response must be concise. 1. What is the ratio of the Rating (1=low 6=high) of Middle East & North Africa (all income levels) in 2009 to that in 2014?
Your answer should be very brief. 1.07. What is the ratio of the Rating (1=low 6=high) of Bolivia in 2009 to that in 2014?
Give a very brief answer. 1.03. What is the ratio of the Rating (1=low 6=high) in Fragile and conflict affected situations in 2010 to that in 2011?
Your answer should be very brief. 0.98. What is the ratio of the Rating (1=low 6=high) of Bolivia in 2010 to that in 2011?
Offer a terse response. 1.03. What is the ratio of the Rating (1=low 6=high) of Guinea in 2010 to that in 2011?
Provide a short and direct response. 1. What is the ratio of the Rating (1=low 6=high) of Middle East & North Africa (all income levels) in 2010 to that in 2012?
Give a very brief answer. 1.06. What is the ratio of the Rating (1=low 6=high) in Bolivia in 2010 to that in 2012?
Provide a succinct answer. 1.03. What is the ratio of the Rating (1=low 6=high) of Fragile and conflict affected situations in 2010 to that in 2013?
Provide a succinct answer. 1. What is the ratio of the Rating (1=low 6=high) of Middle East & North Africa (all income levels) in 2010 to that in 2013?
Provide a short and direct response. 1.04. What is the ratio of the Rating (1=low 6=high) in Bolivia in 2010 to that in 2013?
Keep it short and to the point. 1.03. What is the ratio of the Rating (1=low 6=high) of Guinea in 2010 to that in 2013?
Provide a short and direct response. 0.96. What is the ratio of the Rating (1=low 6=high) in Fragile and conflict affected situations in 2010 to that in 2014?
Offer a very short reply. 1. What is the ratio of the Rating (1=low 6=high) in Middle East & North Africa (all income levels) in 2010 to that in 2014?
Your answer should be very brief. 1.06. What is the ratio of the Rating (1=low 6=high) in Bolivia in 2010 to that in 2014?
Your answer should be compact. 1.03. What is the ratio of the Rating (1=low 6=high) in Fragile and conflict affected situations in 2011 to that in 2012?
Your answer should be very brief. 1.02. What is the ratio of the Rating (1=low 6=high) in Middle East & North Africa (all income levels) in 2011 to that in 2012?
Offer a terse response. 1.06. What is the ratio of the Rating (1=low 6=high) in Bolivia in 2011 to that in 2012?
Your answer should be very brief. 1. What is the ratio of the Rating (1=low 6=high) of Fragile and conflict affected situations in 2011 to that in 2013?
Keep it short and to the point. 1.02. What is the ratio of the Rating (1=low 6=high) of Middle East & North Africa (all income levels) in 2011 to that in 2013?
Give a very brief answer. 1.04. What is the ratio of the Rating (1=low 6=high) of Fragile and conflict affected situations in 2011 to that in 2014?
Offer a very short reply. 1.01. What is the ratio of the Rating (1=low 6=high) in Middle East & North Africa (all income levels) in 2011 to that in 2014?
Make the answer very short. 1.06. What is the ratio of the Rating (1=low 6=high) of Middle East & North Africa (all income levels) in 2012 to that in 2013?
Ensure brevity in your answer.  0.98. What is the ratio of the Rating (1=low 6=high) in Guinea in 2012 to that in 2014?
Offer a very short reply. 0.96. What is the ratio of the Rating (1=low 6=high) in Middle East & North Africa (all income levels) in 2013 to that in 2014?
Offer a very short reply. 1.02. What is the ratio of the Rating (1=low 6=high) of Bolivia in 2013 to that in 2014?
Ensure brevity in your answer.  1. What is the difference between the highest and the second highest Rating (1=low 6=high) of Fragile and conflict affected situations?
Provide a succinct answer. 0.04. What is the difference between the highest and the lowest Rating (1=low 6=high) of Fragile and conflict affected situations?
Your answer should be very brief. 0.13. What is the difference between the highest and the lowest Rating (1=low 6=high) of Bolivia?
Your answer should be compact. 0.1. 